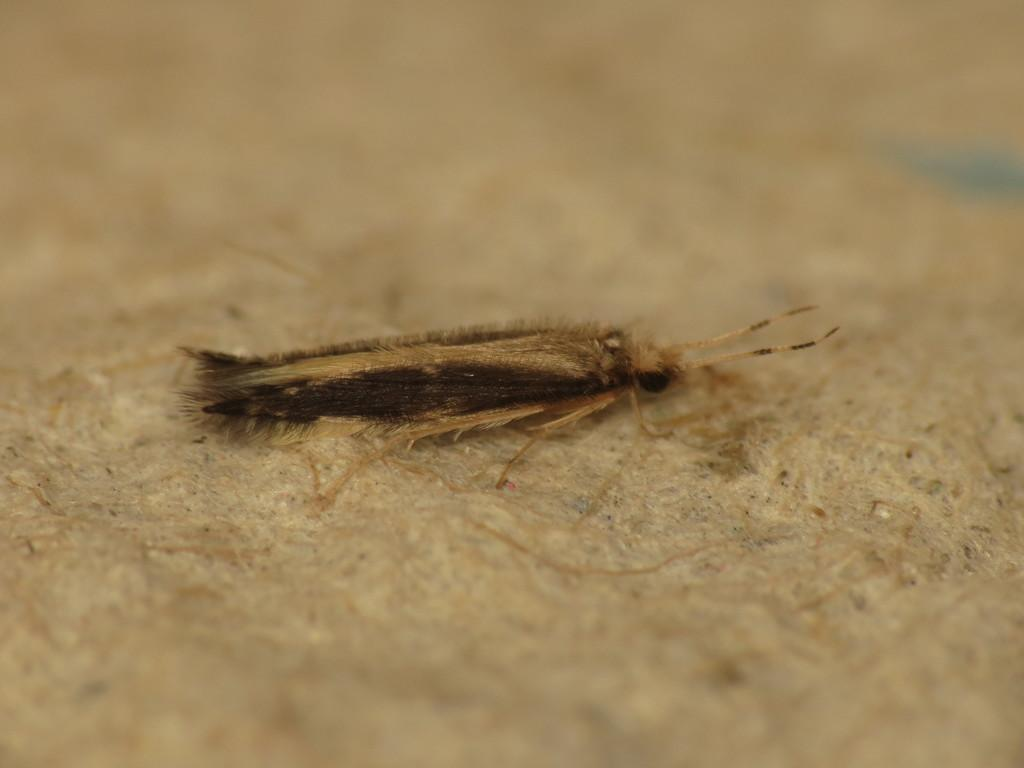What type of creature can be seen in the image? There is an insect in the image. Where is the insect located? The insect is on the ground. Can you describe the background of the image? The background of the image is blurred. What type of stitch is being used to sew the twig in the image? There is no stitch or twig present in the image; it features an insect on the ground with a blurred background. 